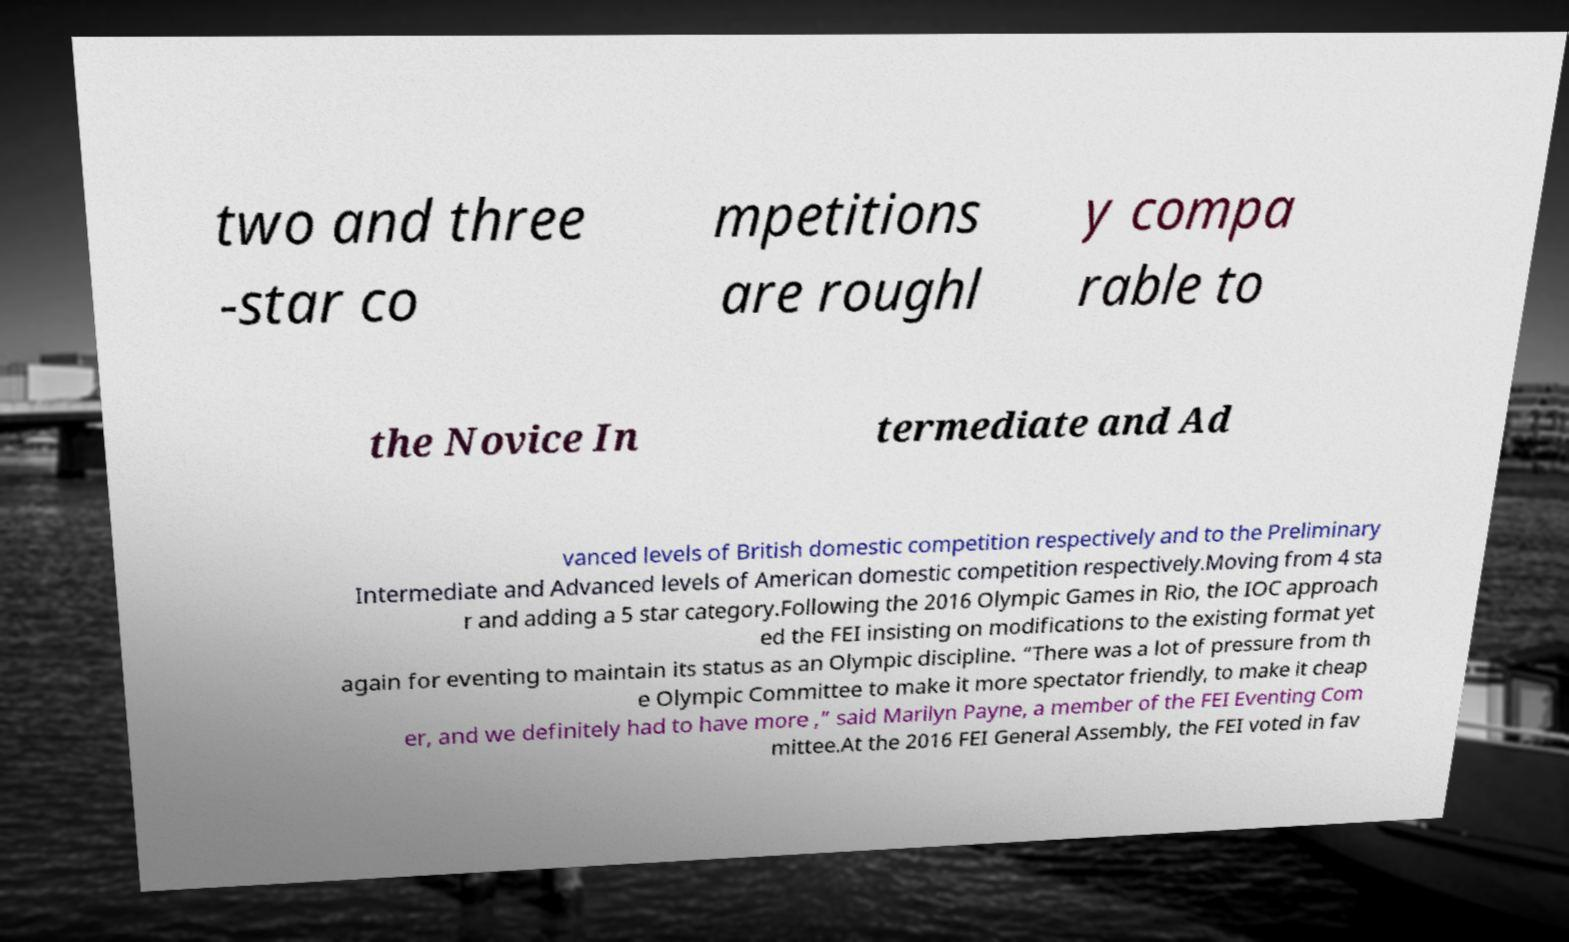Can you accurately transcribe the text from the provided image for me? two and three -star co mpetitions are roughl y compa rable to the Novice In termediate and Ad vanced levels of British domestic competition respectively and to the Preliminary Intermediate and Advanced levels of American domestic competition respectively.Moving from 4 sta r and adding a 5 star category.Following the 2016 Olympic Games in Rio, the IOC approach ed the FEI insisting on modifications to the existing format yet again for eventing to maintain its status as an Olympic discipline. “There was a lot of pressure from th e Olympic Committee to make it more spectator friendly, to make it cheap er, and we definitely had to have more ,” said Marilyn Payne, a member of the FEI Eventing Com mittee.At the 2016 FEI General Assembly, the FEI voted in fav 